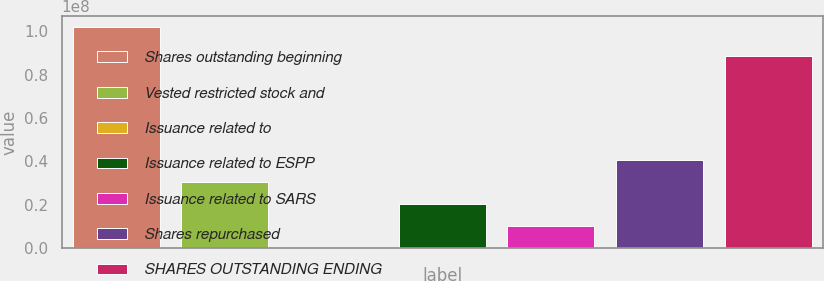Convert chart to OTSL. <chart><loc_0><loc_0><loc_500><loc_500><bar_chart><fcel>Shares outstanding beginning<fcel>Vested restricted stock and<fcel>Issuance related to<fcel>Issuance related to ESPP<fcel>Issuance related to SARS<fcel>Shares repurchased<fcel>SHARES OUTSTANDING ENDING<nl><fcel>1.02e+08<fcel>3.06001e+07<fcel>1.92<fcel>2.04001e+07<fcel>1.02e+07<fcel>4.08001e+07<fcel>8.85244e+07<nl></chart> 